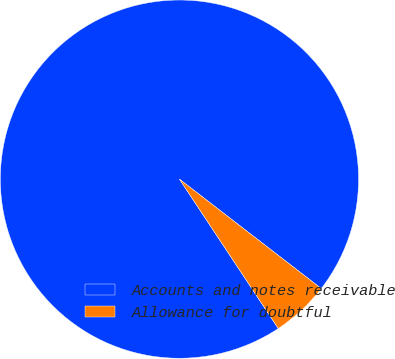Convert chart. <chart><loc_0><loc_0><loc_500><loc_500><pie_chart><fcel>Accounts and notes receivable<fcel>Allowance for doubtful<nl><fcel>94.76%<fcel>5.24%<nl></chart> 